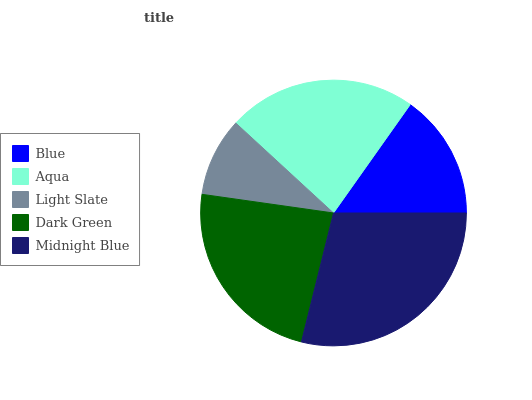Is Light Slate the minimum?
Answer yes or no. Yes. Is Midnight Blue the maximum?
Answer yes or no. Yes. Is Aqua the minimum?
Answer yes or no. No. Is Aqua the maximum?
Answer yes or no. No. Is Aqua greater than Blue?
Answer yes or no. Yes. Is Blue less than Aqua?
Answer yes or no. Yes. Is Blue greater than Aqua?
Answer yes or no. No. Is Aqua less than Blue?
Answer yes or no. No. Is Aqua the high median?
Answer yes or no. Yes. Is Aqua the low median?
Answer yes or no. Yes. Is Light Slate the high median?
Answer yes or no. No. Is Blue the low median?
Answer yes or no. No. 